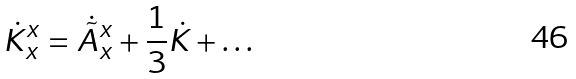<formula> <loc_0><loc_0><loc_500><loc_500>\dot { K } ^ { x } _ { x } = \dot { \tilde { A } } ^ { x } _ { x } + \frac { 1 } { 3 } \dot { K } + \dots</formula> 